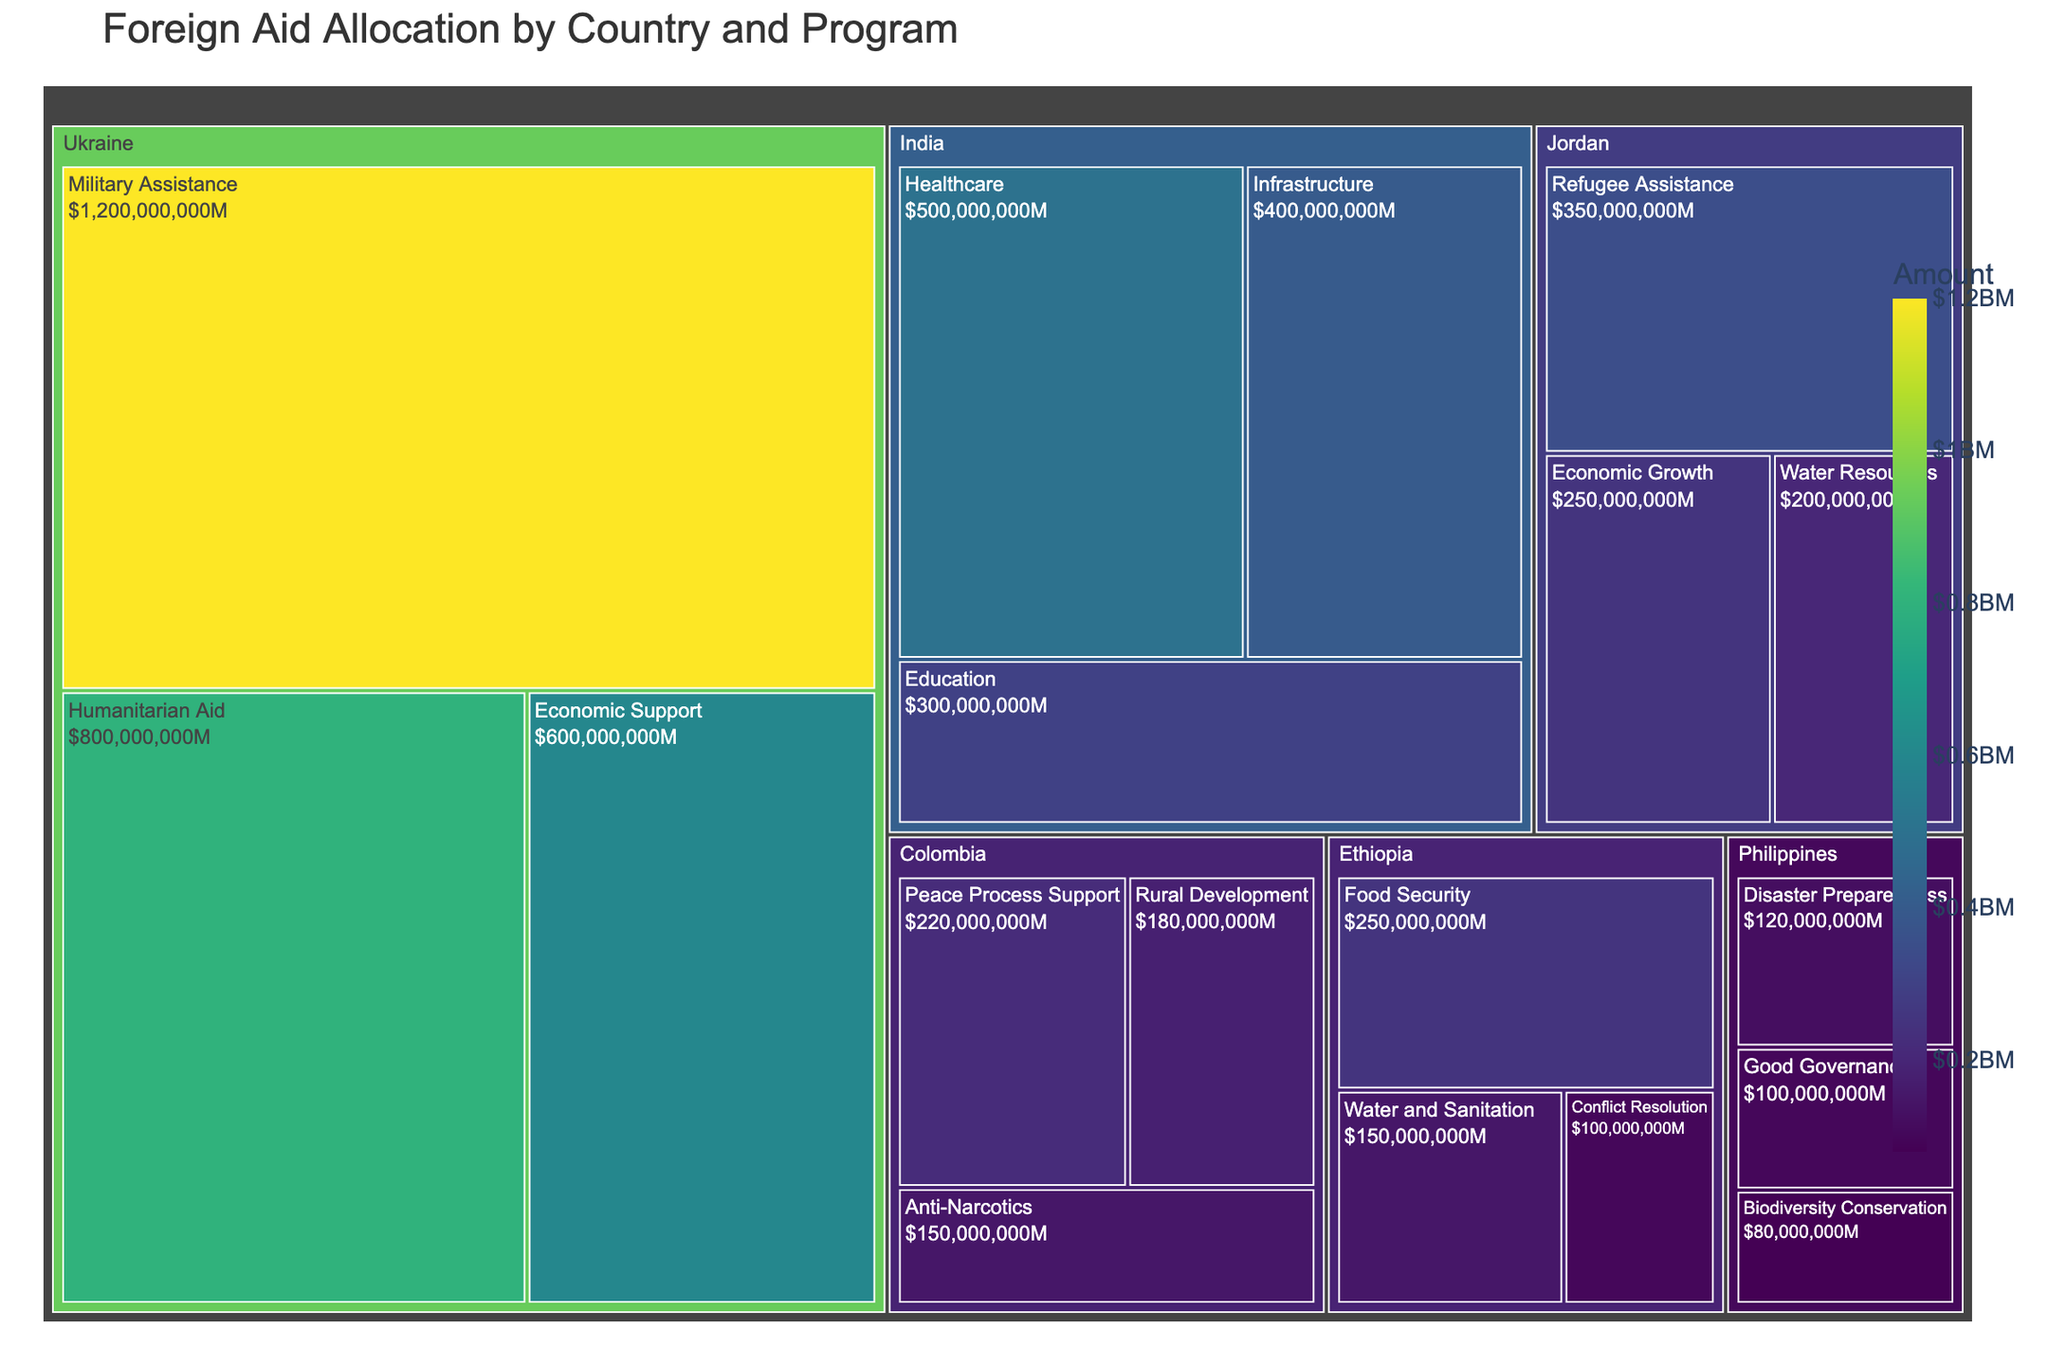How much foreign aid is allocated to India for healthcare? Locate the country "India" in the treemap, then find the program "Healthcare" under it. The amount shown for healthcare is $500,000,000.
Answer: $500M Which country receives the highest amount of foreign aid for any single program? Look for the largest rectangle in the treemap. Ukraine's "Military Assistance" receives the highest amount, which is $1,200,000,000.
Answer: Ukraine What is the total amount of foreign aid allocated to Ukraine? Sum up the amounts for all the programs under Ukraine: $800,000,000 (Humanitarian Aid) + $1,200,000,000 (Military Assistance) + $600,000,000 (Economic Support) = $2,600,000,000.
Answer: $2.6B Among the recipient countries, which has the smallest amount allocated for a single specific program? Find the smallest rectangle in the treemap. This corresponds to the Philippines' "Biodiversity Conservation" program with $80,000,000.
Answer: Philippines Does Ethiopia receive more or less foreign aid than Colombia? Compare the total foreign aid amounts for Ethiopia and Colombia. Ethiopia has: $250,000,000 (Food Security) + $150,000,000 (Water and Sanitation) + $100,000,000 (Conflict Resolution) = $500,000,000. Colombia has: $180,000,000 (Rural Development) + $220,000,000 (Peace Process Support) + $150,000,000 (Anti-Narcotics) = $550,000,000. Ethiopia receives less.
Answer: Less How much aid is allocated to Jordan's Water Resources program? Locate Jordan in the treemap and find the "Water Resources" program. The allocated amount is $200,000,000.
Answer: $200M Compare the allocation for education in India to economic growth in Jordan. Which one is larger? Find India's "Education" and Jordan's "Economic Growth" programs in the treemap. Education in India gets $300,000,000, while economic growth in Jordan gets $250,000,000. Education in India receives more.
Answer: Education in India What is the average foreign aid amount for programs in the Philippines? Sum up the amounts for all programs in the Philippines and divide by the number of programs: $120,000,000 (Disaster Preparedness) + $80,000,000 (Biodiversity Conservation) + $100,000,000 (Good Governance) = $300,000,000. The Philippines has 3 programs, so the average is $300,000,000 / 3 = $100,000,000.
Answer: $100M Which country has the largest variety of programs receiving foreign aid? Count the programs in the treemap for each country. Both India and Ethiopia have 3 programs each, but Ukraine has 3 as well. Therefore, no single country has more programs than the others.
Answer: Multiple countries (India, Ethiopia, Ukraine with 3 programs each) What percentage of total foreign aid is allocated to Military Assistance in Ukraine? First, calculate the total aid across all programs and countries: $500M + $300M + $400M (India) + $800M + $1200M + $600M (Ukraine) + $250M + $150M + $100M (Ethiopia) + $180M + $220M + $150M (Colombia) + $350M + $250M + $200M (Jordan) + $120M + $80M + $100M (Philippines) = $5,750M. Then, find the percentage for Military Assistance in Ukraine: ($1,200M / $5,750M) * 100 ≈ 20.87%.
Answer: 20.87% 